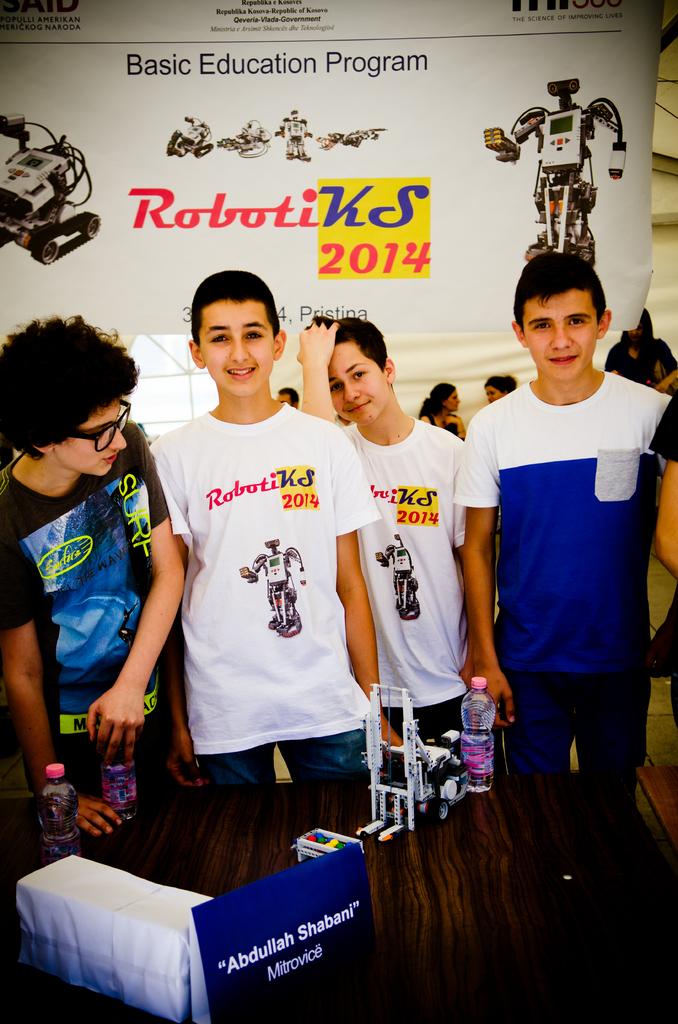What is on the billboard to the left of the robot?
Your answer should be very brief. Robotiks 2014. What year is on the board behind them?
Ensure brevity in your answer.  2014. 